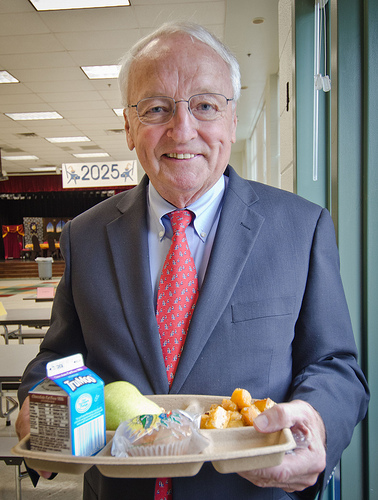<image>
Is there a man on the tray? No. The man is not positioned on the tray. They may be near each other, but the man is not supported by or resting on top of the tray. 